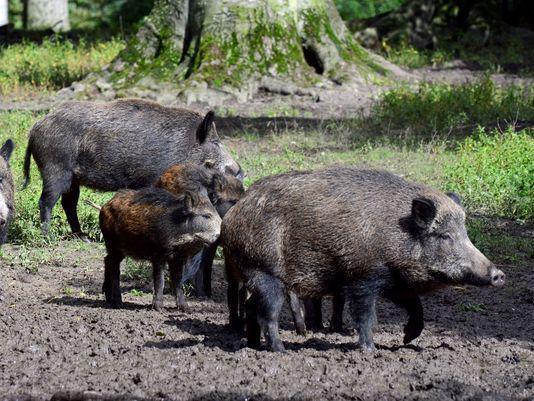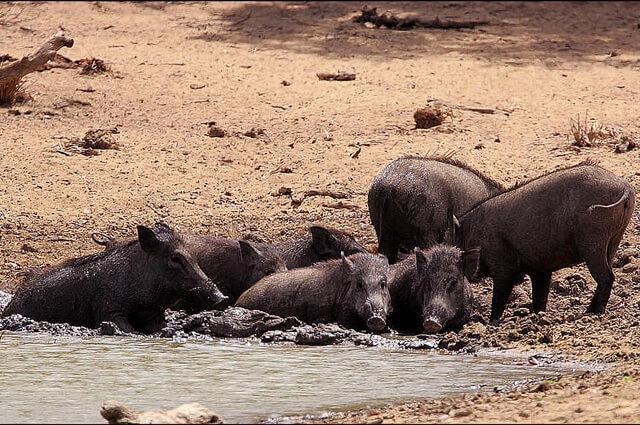The first image is the image on the left, the second image is the image on the right. Given the left and right images, does the statement "A single wild pig stands in the grass in the image on the left." hold true? Answer yes or no. No. The first image is the image on the left, the second image is the image on the right. Given the left and right images, does the statement "Each image shows exactly one wild boar." hold true? Answer yes or no. No. 